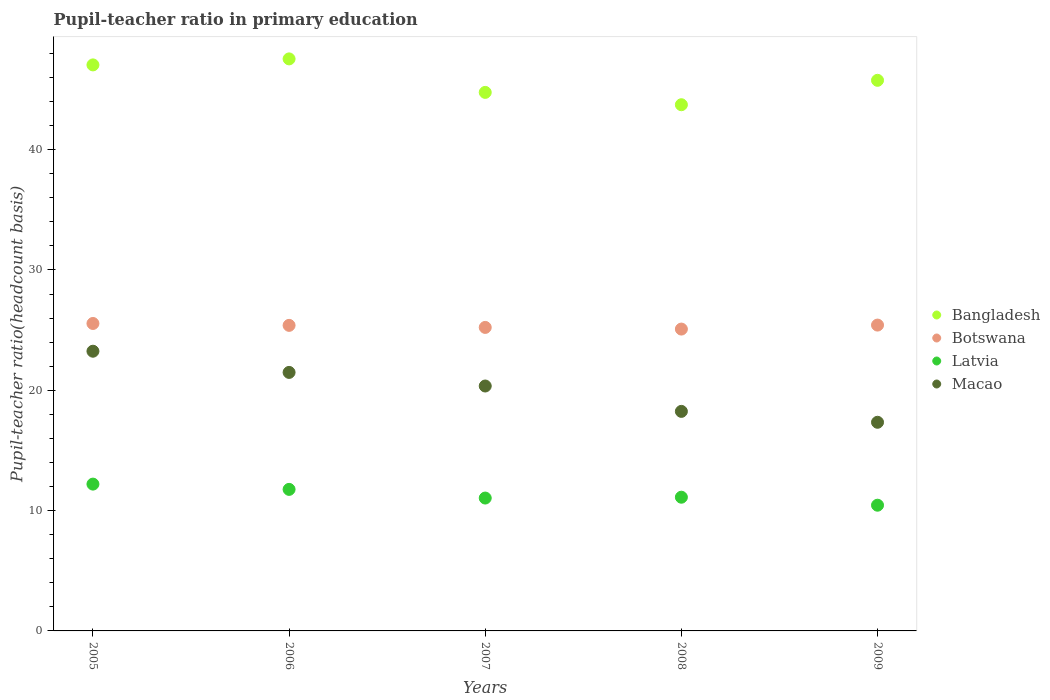What is the pupil-teacher ratio in primary education in Macao in 2007?
Ensure brevity in your answer.  20.35. Across all years, what is the maximum pupil-teacher ratio in primary education in Latvia?
Offer a terse response. 12.2. Across all years, what is the minimum pupil-teacher ratio in primary education in Botswana?
Make the answer very short. 25.08. What is the total pupil-teacher ratio in primary education in Botswana in the graph?
Provide a short and direct response. 126.67. What is the difference between the pupil-teacher ratio in primary education in Macao in 2005 and that in 2007?
Provide a short and direct response. 2.89. What is the difference between the pupil-teacher ratio in primary education in Latvia in 2005 and the pupil-teacher ratio in primary education in Bangladesh in 2008?
Provide a succinct answer. -31.53. What is the average pupil-teacher ratio in primary education in Botswana per year?
Your response must be concise. 25.33. In the year 2007, what is the difference between the pupil-teacher ratio in primary education in Bangladesh and pupil-teacher ratio in primary education in Macao?
Your answer should be compact. 24.4. In how many years, is the pupil-teacher ratio in primary education in Botswana greater than 22?
Keep it short and to the point. 5. What is the ratio of the pupil-teacher ratio in primary education in Macao in 2006 to that in 2009?
Make the answer very short. 1.24. Is the difference between the pupil-teacher ratio in primary education in Bangladesh in 2005 and 2007 greater than the difference between the pupil-teacher ratio in primary education in Macao in 2005 and 2007?
Keep it short and to the point. No. What is the difference between the highest and the second highest pupil-teacher ratio in primary education in Macao?
Provide a short and direct response. 1.76. What is the difference between the highest and the lowest pupil-teacher ratio in primary education in Latvia?
Give a very brief answer. 1.75. In how many years, is the pupil-teacher ratio in primary education in Macao greater than the average pupil-teacher ratio in primary education in Macao taken over all years?
Provide a short and direct response. 3. Is the sum of the pupil-teacher ratio in primary education in Botswana in 2005 and 2008 greater than the maximum pupil-teacher ratio in primary education in Latvia across all years?
Your response must be concise. Yes. Does the pupil-teacher ratio in primary education in Macao monotonically increase over the years?
Your answer should be very brief. No. Is the pupil-teacher ratio in primary education in Bangladesh strictly greater than the pupil-teacher ratio in primary education in Macao over the years?
Offer a terse response. Yes. How many dotlines are there?
Your answer should be compact. 4. How many years are there in the graph?
Make the answer very short. 5. What is the difference between two consecutive major ticks on the Y-axis?
Keep it short and to the point. 10. Does the graph contain any zero values?
Your answer should be very brief. No. Does the graph contain grids?
Offer a very short reply. No. Where does the legend appear in the graph?
Your answer should be compact. Center right. How are the legend labels stacked?
Provide a short and direct response. Vertical. What is the title of the graph?
Your answer should be compact. Pupil-teacher ratio in primary education. What is the label or title of the Y-axis?
Provide a succinct answer. Pupil-teacher ratio(headcount basis). What is the Pupil-teacher ratio(headcount basis) in Bangladesh in 2005?
Your answer should be very brief. 47.04. What is the Pupil-teacher ratio(headcount basis) of Botswana in 2005?
Your answer should be very brief. 25.55. What is the Pupil-teacher ratio(headcount basis) in Latvia in 2005?
Your answer should be very brief. 12.2. What is the Pupil-teacher ratio(headcount basis) in Macao in 2005?
Make the answer very short. 23.24. What is the Pupil-teacher ratio(headcount basis) of Bangladesh in 2006?
Ensure brevity in your answer.  47.54. What is the Pupil-teacher ratio(headcount basis) in Botswana in 2006?
Provide a succinct answer. 25.39. What is the Pupil-teacher ratio(headcount basis) of Latvia in 2006?
Ensure brevity in your answer.  11.76. What is the Pupil-teacher ratio(headcount basis) in Macao in 2006?
Make the answer very short. 21.48. What is the Pupil-teacher ratio(headcount basis) of Bangladesh in 2007?
Offer a very short reply. 44.75. What is the Pupil-teacher ratio(headcount basis) in Botswana in 2007?
Offer a terse response. 25.22. What is the Pupil-teacher ratio(headcount basis) of Latvia in 2007?
Offer a terse response. 11.04. What is the Pupil-teacher ratio(headcount basis) in Macao in 2007?
Make the answer very short. 20.35. What is the Pupil-teacher ratio(headcount basis) of Bangladesh in 2008?
Give a very brief answer. 43.73. What is the Pupil-teacher ratio(headcount basis) of Botswana in 2008?
Ensure brevity in your answer.  25.08. What is the Pupil-teacher ratio(headcount basis) of Latvia in 2008?
Your response must be concise. 11.11. What is the Pupil-teacher ratio(headcount basis) of Macao in 2008?
Your answer should be very brief. 18.24. What is the Pupil-teacher ratio(headcount basis) of Bangladesh in 2009?
Provide a short and direct response. 45.76. What is the Pupil-teacher ratio(headcount basis) of Botswana in 2009?
Offer a very short reply. 25.42. What is the Pupil-teacher ratio(headcount basis) in Latvia in 2009?
Give a very brief answer. 10.45. What is the Pupil-teacher ratio(headcount basis) of Macao in 2009?
Offer a very short reply. 17.34. Across all years, what is the maximum Pupil-teacher ratio(headcount basis) in Bangladesh?
Provide a succinct answer. 47.54. Across all years, what is the maximum Pupil-teacher ratio(headcount basis) in Botswana?
Your answer should be very brief. 25.55. Across all years, what is the maximum Pupil-teacher ratio(headcount basis) of Latvia?
Provide a succinct answer. 12.2. Across all years, what is the maximum Pupil-teacher ratio(headcount basis) in Macao?
Provide a succinct answer. 23.24. Across all years, what is the minimum Pupil-teacher ratio(headcount basis) of Bangladesh?
Keep it short and to the point. 43.73. Across all years, what is the minimum Pupil-teacher ratio(headcount basis) of Botswana?
Offer a very short reply. 25.08. Across all years, what is the minimum Pupil-teacher ratio(headcount basis) in Latvia?
Give a very brief answer. 10.45. Across all years, what is the minimum Pupil-teacher ratio(headcount basis) in Macao?
Your answer should be compact. 17.34. What is the total Pupil-teacher ratio(headcount basis) in Bangladesh in the graph?
Provide a short and direct response. 228.82. What is the total Pupil-teacher ratio(headcount basis) in Botswana in the graph?
Provide a succinct answer. 126.67. What is the total Pupil-teacher ratio(headcount basis) of Latvia in the graph?
Make the answer very short. 56.57. What is the total Pupil-teacher ratio(headcount basis) of Macao in the graph?
Your response must be concise. 100.67. What is the difference between the Pupil-teacher ratio(headcount basis) in Bangladesh in 2005 and that in 2006?
Your response must be concise. -0.5. What is the difference between the Pupil-teacher ratio(headcount basis) of Botswana in 2005 and that in 2006?
Make the answer very short. 0.16. What is the difference between the Pupil-teacher ratio(headcount basis) in Latvia in 2005 and that in 2006?
Keep it short and to the point. 0.44. What is the difference between the Pupil-teacher ratio(headcount basis) in Macao in 2005 and that in 2006?
Your answer should be compact. 1.76. What is the difference between the Pupil-teacher ratio(headcount basis) of Bangladesh in 2005 and that in 2007?
Keep it short and to the point. 2.28. What is the difference between the Pupil-teacher ratio(headcount basis) of Botswana in 2005 and that in 2007?
Your answer should be compact. 0.33. What is the difference between the Pupil-teacher ratio(headcount basis) in Latvia in 2005 and that in 2007?
Your response must be concise. 1.16. What is the difference between the Pupil-teacher ratio(headcount basis) of Macao in 2005 and that in 2007?
Offer a very short reply. 2.89. What is the difference between the Pupil-teacher ratio(headcount basis) of Bangladesh in 2005 and that in 2008?
Offer a very short reply. 3.31. What is the difference between the Pupil-teacher ratio(headcount basis) in Botswana in 2005 and that in 2008?
Keep it short and to the point. 0.47. What is the difference between the Pupil-teacher ratio(headcount basis) of Latvia in 2005 and that in 2008?
Offer a terse response. 1.09. What is the difference between the Pupil-teacher ratio(headcount basis) of Macao in 2005 and that in 2008?
Offer a terse response. 5. What is the difference between the Pupil-teacher ratio(headcount basis) of Bangladesh in 2005 and that in 2009?
Offer a terse response. 1.28. What is the difference between the Pupil-teacher ratio(headcount basis) of Botswana in 2005 and that in 2009?
Ensure brevity in your answer.  0.13. What is the difference between the Pupil-teacher ratio(headcount basis) in Latvia in 2005 and that in 2009?
Ensure brevity in your answer.  1.75. What is the difference between the Pupil-teacher ratio(headcount basis) in Macao in 2005 and that in 2009?
Ensure brevity in your answer.  5.91. What is the difference between the Pupil-teacher ratio(headcount basis) in Bangladesh in 2006 and that in 2007?
Offer a terse response. 2.78. What is the difference between the Pupil-teacher ratio(headcount basis) of Botswana in 2006 and that in 2007?
Make the answer very short. 0.17. What is the difference between the Pupil-teacher ratio(headcount basis) in Latvia in 2006 and that in 2007?
Your answer should be very brief. 0.72. What is the difference between the Pupil-teacher ratio(headcount basis) in Macao in 2006 and that in 2007?
Your answer should be compact. 1.13. What is the difference between the Pupil-teacher ratio(headcount basis) in Bangladesh in 2006 and that in 2008?
Keep it short and to the point. 3.81. What is the difference between the Pupil-teacher ratio(headcount basis) of Botswana in 2006 and that in 2008?
Keep it short and to the point. 0.31. What is the difference between the Pupil-teacher ratio(headcount basis) in Latvia in 2006 and that in 2008?
Give a very brief answer. 0.65. What is the difference between the Pupil-teacher ratio(headcount basis) in Macao in 2006 and that in 2008?
Your response must be concise. 3.24. What is the difference between the Pupil-teacher ratio(headcount basis) in Bangladesh in 2006 and that in 2009?
Ensure brevity in your answer.  1.78. What is the difference between the Pupil-teacher ratio(headcount basis) in Botswana in 2006 and that in 2009?
Your answer should be very brief. -0.02. What is the difference between the Pupil-teacher ratio(headcount basis) in Latvia in 2006 and that in 2009?
Give a very brief answer. 1.31. What is the difference between the Pupil-teacher ratio(headcount basis) of Macao in 2006 and that in 2009?
Provide a succinct answer. 4.14. What is the difference between the Pupil-teacher ratio(headcount basis) in Bangladesh in 2007 and that in 2008?
Make the answer very short. 1.03. What is the difference between the Pupil-teacher ratio(headcount basis) of Botswana in 2007 and that in 2008?
Ensure brevity in your answer.  0.14. What is the difference between the Pupil-teacher ratio(headcount basis) in Latvia in 2007 and that in 2008?
Make the answer very short. -0.07. What is the difference between the Pupil-teacher ratio(headcount basis) of Macao in 2007 and that in 2008?
Provide a short and direct response. 2.11. What is the difference between the Pupil-teacher ratio(headcount basis) of Bangladesh in 2007 and that in 2009?
Offer a very short reply. -1. What is the difference between the Pupil-teacher ratio(headcount basis) of Botswana in 2007 and that in 2009?
Provide a short and direct response. -0.19. What is the difference between the Pupil-teacher ratio(headcount basis) in Latvia in 2007 and that in 2009?
Give a very brief answer. 0.59. What is the difference between the Pupil-teacher ratio(headcount basis) in Macao in 2007 and that in 2009?
Keep it short and to the point. 3.01. What is the difference between the Pupil-teacher ratio(headcount basis) in Bangladesh in 2008 and that in 2009?
Give a very brief answer. -2.03. What is the difference between the Pupil-teacher ratio(headcount basis) in Botswana in 2008 and that in 2009?
Provide a succinct answer. -0.33. What is the difference between the Pupil-teacher ratio(headcount basis) in Latvia in 2008 and that in 2009?
Make the answer very short. 0.66. What is the difference between the Pupil-teacher ratio(headcount basis) in Macao in 2008 and that in 2009?
Make the answer very short. 0.91. What is the difference between the Pupil-teacher ratio(headcount basis) of Bangladesh in 2005 and the Pupil-teacher ratio(headcount basis) of Botswana in 2006?
Your answer should be very brief. 21.65. What is the difference between the Pupil-teacher ratio(headcount basis) in Bangladesh in 2005 and the Pupil-teacher ratio(headcount basis) in Latvia in 2006?
Your answer should be compact. 35.28. What is the difference between the Pupil-teacher ratio(headcount basis) in Bangladesh in 2005 and the Pupil-teacher ratio(headcount basis) in Macao in 2006?
Offer a very short reply. 25.56. What is the difference between the Pupil-teacher ratio(headcount basis) in Botswana in 2005 and the Pupil-teacher ratio(headcount basis) in Latvia in 2006?
Offer a terse response. 13.79. What is the difference between the Pupil-teacher ratio(headcount basis) in Botswana in 2005 and the Pupil-teacher ratio(headcount basis) in Macao in 2006?
Keep it short and to the point. 4.07. What is the difference between the Pupil-teacher ratio(headcount basis) of Latvia in 2005 and the Pupil-teacher ratio(headcount basis) of Macao in 2006?
Give a very brief answer. -9.28. What is the difference between the Pupil-teacher ratio(headcount basis) in Bangladesh in 2005 and the Pupil-teacher ratio(headcount basis) in Botswana in 2007?
Offer a very short reply. 21.82. What is the difference between the Pupil-teacher ratio(headcount basis) of Bangladesh in 2005 and the Pupil-teacher ratio(headcount basis) of Latvia in 2007?
Provide a short and direct response. 36. What is the difference between the Pupil-teacher ratio(headcount basis) of Bangladesh in 2005 and the Pupil-teacher ratio(headcount basis) of Macao in 2007?
Offer a very short reply. 26.69. What is the difference between the Pupil-teacher ratio(headcount basis) in Botswana in 2005 and the Pupil-teacher ratio(headcount basis) in Latvia in 2007?
Give a very brief answer. 14.51. What is the difference between the Pupil-teacher ratio(headcount basis) in Botswana in 2005 and the Pupil-teacher ratio(headcount basis) in Macao in 2007?
Provide a succinct answer. 5.2. What is the difference between the Pupil-teacher ratio(headcount basis) in Latvia in 2005 and the Pupil-teacher ratio(headcount basis) in Macao in 2007?
Keep it short and to the point. -8.15. What is the difference between the Pupil-teacher ratio(headcount basis) of Bangladesh in 2005 and the Pupil-teacher ratio(headcount basis) of Botswana in 2008?
Provide a succinct answer. 21.95. What is the difference between the Pupil-teacher ratio(headcount basis) of Bangladesh in 2005 and the Pupil-teacher ratio(headcount basis) of Latvia in 2008?
Provide a short and direct response. 35.93. What is the difference between the Pupil-teacher ratio(headcount basis) in Bangladesh in 2005 and the Pupil-teacher ratio(headcount basis) in Macao in 2008?
Give a very brief answer. 28.79. What is the difference between the Pupil-teacher ratio(headcount basis) in Botswana in 2005 and the Pupil-teacher ratio(headcount basis) in Latvia in 2008?
Provide a succinct answer. 14.44. What is the difference between the Pupil-teacher ratio(headcount basis) of Botswana in 2005 and the Pupil-teacher ratio(headcount basis) of Macao in 2008?
Provide a short and direct response. 7.31. What is the difference between the Pupil-teacher ratio(headcount basis) of Latvia in 2005 and the Pupil-teacher ratio(headcount basis) of Macao in 2008?
Give a very brief answer. -6.04. What is the difference between the Pupil-teacher ratio(headcount basis) of Bangladesh in 2005 and the Pupil-teacher ratio(headcount basis) of Botswana in 2009?
Your answer should be very brief. 21.62. What is the difference between the Pupil-teacher ratio(headcount basis) in Bangladesh in 2005 and the Pupil-teacher ratio(headcount basis) in Latvia in 2009?
Provide a short and direct response. 36.59. What is the difference between the Pupil-teacher ratio(headcount basis) in Bangladesh in 2005 and the Pupil-teacher ratio(headcount basis) in Macao in 2009?
Offer a terse response. 29.7. What is the difference between the Pupil-teacher ratio(headcount basis) of Botswana in 2005 and the Pupil-teacher ratio(headcount basis) of Latvia in 2009?
Provide a succinct answer. 15.1. What is the difference between the Pupil-teacher ratio(headcount basis) in Botswana in 2005 and the Pupil-teacher ratio(headcount basis) in Macao in 2009?
Your answer should be very brief. 8.21. What is the difference between the Pupil-teacher ratio(headcount basis) of Latvia in 2005 and the Pupil-teacher ratio(headcount basis) of Macao in 2009?
Provide a short and direct response. -5.14. What is the difference between the Pupil-teacher ratio(headcount basis) in Bangladesh in 2006 and the Pupil-teacher ratio(headcount basis) in Botswana in 2007?
Give a very brief answer. 22.32. What is the difference between the Pupil-teacher ratio(headcount basis) of Bangladesh in 2006 and the Pupil-teacher ratio(headcount basis) of Latvia in 2007?
Keep it short and to the point. 36.5. What is the difference between the Pupil-teacher ratio(headcount basis) of Bangladesh in 2006 and the Pupil-teacher ratio(headcount basis) of Macao in 2007?
Give a very brief answer. 27.19. What is the difference between the Pupil-teacher ratio(headcount basis) of Botswana in 2006 and the Pupil-teacher ratio(headcount basis) of Latvia in 2007?
Your answer should be very brief. 14.35. What is the difference between the Pupil-teacher ratio(headcount basis) of Botswana in 2006 and the Pupil-teacher ratio(headcount basis) of Macao in 2007?
Ensure brevity in your answer.  5.04. What is the difference between the Pupil-teacher ratio(headcount basis) of Latvia in 2006 and the Pupil-teacher ratio(headcount basis) of Macao in 2007?
Ensure brevity in your answer.  -8.59. What is the difference between the Pupil-teacher ratio(headcount basis) in Bangladesh in 2006 and the Pupil-teacher ratio(headcount basis) in Botswana in 2008?
Make the answer very short. 22.45. What is the difference between the Pupil-teacher ratio(headcount basis) in Bangladesh in 2006 and the Pupil-teacher ratio(headcount basis) in Latvia in 2008?
Your response must be concise. 36.43. What is the difference between the Pupil-teacher ratio(headcount basis) in Bangladesh in 2006 and the Pupil-teacher ratio(headcount basis) in Macao in 2008?
Ensure brevity in your answer.  29.29. What is the difference between the Pupil-teacher ratio(headcount basis) in Botswana in 2006 and the Pupil-teacher ratio(headcount basis) in Latvia in 2008?
Make the answer very short. 14.28. What is the difference between the Pupil-teacher ratio(headcount basis) in Botswana in 2006 and the Pupil-teacher ratio(headcount basis) in Macao in 2008?
Offer a terse response. 7.15. What is the difference between the Pupil-teacher ratio(headcount basis) of Latvia in 2006 and the Pupil-teacher ratio(headcount basis) of Macao in 2008?
Provide a succinct answer. -6.48. What is the difference between the Pupil-teacher ratio(headcount basis) in Bangladesh in 2006 and the Pupil-teacher ratio(headcount basis) in Botswana in 2009?
Give a very brief answer. 22.12. What is the difference between the Pupil-teacher ratio(headcount basis) of Bangladesh in 2006 and the Pupil-teacher ratio(headcount basis) of Latvia in 2009?
Provide a short and direct response. 37.09. What is the difference between the Pupil-teacher ratio(headcount basis) in Bangladesh in 2006 and the Pupil-teacher ratio(headcount basis) in Macao in 2009?
Your response must be concise. 30.2. What is the difference between the Pupil-teacher ratio(headcount basis) of Botswana in 2006 and the Pupil-teacher ratio(headcount basis) of Latvia in 2009?
Offer a very short reply. 14.95. What is the difference between the Pupil-teacher ratio(headcount basis) in Botswana in 2006 and the Pupil-teacher ratio(headcount basis) in Macao in 2009?
Offer a very short reply. 8.05. What is the difference between the Pupil-teacher ratio(headcount basis) in Latvia in 2006 and the Pupil-teacher ratio(headcount basis) in Macao in 2009?
Offer a very short reply. -5.58. What is the difference between the Pupil-teacher ratio(headcount basis) of Bangladesh in 2007 and the Pupil-teacher ratio(headcount basis) of Botswana in 2008?
Ensure brevity in your answer.  19.67. What is the difference between the Pupil-teacher ratio(headcount basis) in Bangladesh in 2007 and the Pupil-teacher ratio(headcount basis) in Latvia in 2008?
Offer a very short reply. 33.64. What is the difference between the Pupil-teacher ratio(headcount basis) of Bangladesh in 2007 and the Pupil-teacher ratio(headcount basis) of Macao in 2008?
Your answer should be very brief. 26.51. What is the difference between the Pupil-teacher ratio(headcount basis) in Botswana in 2007 and the Pupil-teacher ratio(headcount basis) in Latvia in 2008?
Make the answer very short. 14.11. What is the difference between the Pupil-teacher ratio(headcount basis) in Botswana in 2007 and the Pupil-teacher ratio(headcount basis) in Macao in 2008?
Your answer should be compact. 6.98. What is the difference between the Pupil-teacher ratio(headcount basis) of Latvia in 2007 and the Pupil-teacher ratio(headcount basis) of Macao in 2008?
Your answer should be very brief. -7.2. What is the difference between the Pupil-teacher ratio(headcount basis) of Bangladesh in 2007 and the Pupil-teacher ratio(headcount basis) of Botswana in 2009?
Provide a short and direct response. 19.34. What is the difference between the Pupil-teacher ratio(headcount basis) in Bangladesh in 2007 and the Pupil-teacher ratio(headcount basis) in Latvia in 2009?
Offer a very short reply. 34.31. What is the difference between the Pupil-teacher ratio(headcount basis) in Bangladesh in 2007 and the Pupil-teacher ratio(headcount basis) in Macao in 2009?
Ensure brevity in your answer.  27.42. What is the difference between the Pupil-teacher ratio(headcount basis) of Botswana in 2007 and the Pupil-teacher ratio(headcount basis) of Latvia in 2009?
Your answer should be very brief. 14.77. What is the difference between the Pupil-teacher ratio(headcount basis) in Botswana in 2007 and the Pupil-teacher ratio(headcount basis) in Macao in 2009?
Ensure brevity in your answer.  7.88. What is the difference between the Pupil-teacher ratio(headcount basis) of Latvia in 2007 and the Pupil-teacher ratio(headcount basis) of Macao in 2009?
Make the answer very short. -6.3. What is the difference between the Pupil-teacher ratio(headcount basis) in Bangladesh in 2008 and the Pupil-teacher ratio(headcount basis) in Botswana in 2009?
Ensure brevity in your answer.  18.31. What is the difference between the Pupil-teacher ratio(headcount basis) of Bangladesh in 2008 and the Pupil-teacher ratio(headcount basis) of Latvia in 2009?
Offer a very short reply. 33.28. What is the difference between the Pupil-teacher ratio(headcount basis) in Bangladesh in 2008 and the Pupil-teacher ratio(headcount basis) in Macao in 2009?
Give a very brief answer. 26.39. What is the difference between the Pupil-teacher ratio(headcount basis) of Botswana in 2008 and the Pupil-teacher ratio(headcount basis) of Latvia in 2009?
Give a very brief answer. 14.64. What is the difference between the Pupil-teacher ratio(headcount basis) in Botswana in 2008 and the Pupil-teacher ratio(headcount basis) in Macao in 2009?
Ensure brevity in your answer.  7.75. What is the difference between the Pupil-teacher ratio(headcount basis) of Latvia in 2008 and the Pupil-teacher ratio(headcount basis) of Macao in 2009?
Offer a terse response. -6.23. What is the average Pupil-teacher ratio(headcount basis) in Bangladesh per year?
Your answer should be compact. 45.76. What is the average Pupil-teacher ratio(headcount basis) of Botswana per year?
Provide a succinct answer. 25.33. What is the average Pupil-teacher ratio(headcount basis) in Latvia per year?
Ensure brevity in your answer.  11.31. What is the average Pupil-teacher ratio(headcount basis) in Macao per year?
Make the answer very short. 20.13. In the year 2005, what is the difference between the Pupil-teacher ratio(headcount basis) in Bangladesh and Pupil-teacher ratio(headcount basis) in Botswana?
Give a very brief answer. 21.49. In the year 2005, what is the difference between the Pupil-teacher ratio(headcount basis) of Bangladesh and Pupil-teacher ratio(headcount basis) of Latvia?
Your answer should be very brief. 34.84. In the year 2005, what is the difference between the Pupil-teacher ratio(headcount basis) of Bangladesh and Pupil-teacher ratio(headcount basis) of Macao?
Provide a short and direct response. 23.79. In the year 2005, what is the difference between the Pupil-teacher ratio(headcount basis) in Botswana and Pupil-teacher ratio(headcount basis) in Latvia?
Your response must be concise. 13.35. In the year 2005, what is the difference between the Pupil-teacher ratio(headcount basis) of Botswana and Pupil-teacher ratio(headcount basis) of Macao?
Give a very brief answer. 2.31. In the year 2005, what is the difference between the Pupil-teacher ratio(headcount basis) of Latvia and Pupil-teacher ratio(headcount basis) of Macao?
Offer a very short reply. -11.04. In the year 2006, what is the difference between the Pupil-teacher ratio(headcount basis) in Bangladesh and Pupil-teacher ratio(headcount basis) in Botswana?
Offer a very short reply. 22.15. In the year 2006, what is the difference between the Pupil-teacher ratio(headcount basis) of Bangladesh and Pupil-teacher ratio(headcount basis) of Latvia?
Make the answer very short. 35.78. In the year 2006, what is the difference between the Pupil-teacher ratio(headcount basis) of Bangladesh and Pupil-teacher ratio(headcount basis) of Macao?
Make the answer very short. 26.06. In the year 2006, what is the difference between the Pupil-teacher ratio(headcount basis) of Botswana and Pupil-teacher ratio(headcount basis) of Latvia?
Ensure brevity in your answer.  13.63. In the year 2006, what is the difference between the Pupil-teacher ratio(headcount basis) in Botswana and Pupil-teacher ratio(headcount basis) in Macao?
Provide a succinct answer. 3.91. In the year 2006, what is the difference between the Pupil-teacher ratio(headcount basis) of Latvia and Pupil-teacher ratio(headcount basis) of Macao?
Provide a succinct answer. -9.72. In the year 2007, what is the difference between the Pupil-teacher ratio(headcount basis) of Bangladesh and Pupil-teacher ratio(headcount basis) of Botswana?
Your response must be concise. 19.53. In the year 2007, what is the difference between the Pupil-teacher ratio(headcount basis) in Bangladesh and Pupil-teacher ratio(headcount basis) in Latvia?
Ensure brevity in your answer.  33.71. In the year 2007, what is the difference between the Pupil-teacher ratio(headcount basis) in Bangladesh and Pupil-teacher ratio(headcount basis) in Macao?
Ensure brevity in your answer.  24.4. In the year 2007, what is the difference between the Pupil-teacher ratio(headcount basis) in Botswana and Pupil-teacher ratio(headcount basis) in Latvia?
Ensure brevity in your answer.  14.18. In the year 2007, what is the difference between the Pupil-teacher ratio(headcount basis) in Botswana and Pupil-teacher ratio(headcount basis) in Macao?
Make the answer very short. 4.87. In the year 2007, what is the difference between the Pupil-teacher ratio(headcount basis) in Latvia and Pupil-teacher ratio(headcount basis) in Macao?
Offer a terse response. -9.31. In the year 2008, what is the difference between the Pupil-teacher ratio(headcount basis) in Bangladesh and Pupil-teacher ratio(headcount basis) in Botswana?
Offer a very short reply. 18.64. In the year 2008, what is the difference between the Pupil-teacher ratio(headcount basis) of Bangladesh and Pupil-teacher ratio(headcount basis) of Latvia?
Give a very brief answer. 32.62. In the year 2008, what is the difference between the Pupil-teacher ratio(headcount basis) of Bangladesh and Pupil-teacher ratio(headcount basis) of Macao?
Keep it short and to the point. 25.48. In the year 2008, what is the difference between the Pupil-teacher ratio(headcount basis) of Botswana and Pupil-teacher ratio(headcount basis) of Latvia?
Offer a very short reply. 13.97. In the year 2008, what is the difference between the Pupil-teacher ratio(headcount basis) in Botswana and Pupil-teacher ratio(headcount basis) in Macao?
Provide a short and direct response. 6.84. In the year 2008, what is the difference between the Pupil-teacher ratio(headcount basis) in Latvia and Pupil-teacher ratio(headcount basis) in Macao?
Provide a succinct answer. -7.13. In the year 2009, what is the difference between the Pupil-teacher ratio(headcount basis) in Bangladesh and Pupil-teacher ratio(headcount basis) in Botswana?
Provide a succinct answer. 20.34. In the year 2009, what is the difference between the Pupil-teacher ratio(headcount basis) in Bangladesh and Pupil-teacher ratio(headcount basis) in Latvia?
Offer a terse response. 35.31. In the year 2009, what is the difference between the Pupil-teacher ratio(headcount basis) in Bangladesh and Pupil-teacher ratio(headcount basis) in Macao?
Give a very brief answer. 28.42. In the year 2009, what is the difference between the Pupil-teacher ratio(headcount basis) of Botswana and Pupil-teacher ratio(headcount basis) of Latvia?
Provide a succinct answer. 14.97. In the year 2009, what is the difference between the Pupil-teacher ratio(headcount basis) in Botswana and Pupil-teacher ratio(headcount basis) in Macao?
Your answer should be very brief. 8.08. In the year 2009, what is the difference between the Pupil-teacher ratio(headcount basis) of Latvia and Pupil-teacher ratio(headcount basis) of Macao?
Make the answer very short. -6.89. What is the ratio of the Pupil-teacher ratio(headcount basis) of Botswana in 2005 to that in 2006?
Ensure brevity in your answer.  1.01. What is the ratio of the Pupil-teacher ratio(headcount basis) of Latvia in 2005 to that in 2006?
Offer a very short reply. 1.04. What is the ratio of the Pupil-teacher ratio(headcount basis) of Macao in 2005 to that in 2006?
Provide a short and direct response. 1.08. What is the ratio of the Pupil-teacher ratio(headcount basis) of Bangladesh in 2005 to that in 2007?
Your answer should be compact. 1.05. What is the ratio of the Pupil-teacher ratio(headcount basis) in Botswana in 2005 to that in 2007?
Keep it short and to the point. 1.01. What is the ratio of the Pupil-teacher ratio(headcount basis) of Latvia in 2005 to that in 2007?
Provide a succinct answer. 1.1. What is the ratio of the Pupil-teacher ratio(headcount basis) of Macao in 2005 to that in 2007?
Give a very brief answer. 1.14. What is the ratio of the Pupil-teacher ratio(headcount basis) in Bangladesh in 2005 to that in 2008?
Offer a terse response. 1.08. What is the ratio of the Pupil-teacher ratio(headcount basis) of Botswana in 2005 to that in 2008?
Provide a succinct answer. 1.02. What is the ratio of the Pupil-teacher ratio(headcount basis) of Latvia in 2005 to that in 2008?
Ensure brevity in your answer.  1.1. What is the ratio of the Pupil-teacher ratio(headcount basis) in Macao in 2005 to that in 2008?
Ensure brevity in your answer.  1.27. What is the ratio of the Pupil-teacher ratio(headcount basis) in Bangladesh in 2005 to that in 2009?
Ensure brevity in your answer.  1.03. What is the ratio of the Pupil-teacher ratio(headcount basis) of Botswana in 2005 to that in 2009?
Offer a very short reply. 1.01. What is the ratio of the Pupil-teacher ratio(headcount basis) of Latvia in 2005 to that in 2009?
Provide a short and direct response. 1.17. What is the ratio of the Pupil-teacher ratio(headcount basis) in Macao in 2005 to that in 2009?
Your answer should be very brief. 1.34. What is the ratio of the Pupil-teacher ratio(headcount basis) of Bangladesh in 2006 to that in 2007?
Your answer should be compact. 1.06. What is the ratio of the Pupil-teacher ratio(headcount basis) in Botswana in 2006 to that in 2007?
Your answer should be compact. 1.01. What is the ratio of the Pupil-teacher ratio(headcount basis) of Latvia in 2006 to that in 2007?
Provide a short and direct response. 1.07. What is the ratio of the Pupil-teacher ratio(headcount basis) of Macao in 2006 to that in 2007?
Provide a succinct answer. 1.06. What is the ratio of the Pupil-teacher ratio(headcount basis) in Bangladesh in 2006 to that in 2008?
Offer a terse response. 1.09. What is the ratio of the Pupil-teacher ratio(headcount basis) in Botswana in 2006 to that in 2008?
Provide a succinct answer. 1.01. What is the ratio of the Pupil-teacher ratio(headcount basis) in Latvia in 2006 to that in 2008?
Provide a short and direct response. 1.06. What is the ratio of the Pupil-teacher ratio(headcount basis) in Macao in 2006 to that in 2008?
Offer a very short reply. 1.18. What is the ratio of the Pupil-teacher ratio(headcount basis) in Bangladesh in 2006 to that in 2009?
Give a very brief answer. 1.04. What is the ratio of the Pupil-teacher ratio(headcount basis) in Latvia in 2006 to that in 2009?
Offer a very short reply. 1.13. What is the ratio of the Pupil-teacher ratio(headcount basis) of Macao in 2006 to that in 2009?
Give a very brief answer. 1.24. What is the ratio of the Pupil-teacher ratio(headcount basis) in Bangladesh in 2007 to that in 2008?
Provide a succinct answer. 1.02. What is the ratio of the Pupil-teacher ratio(headcount basis) of Latvia in 2007 to that in 2008?
Provide a succinct answer. 0.99. What is the ratio of the Pupil-teacher ratio(headcount basis) in Macao in 2007 to that in 2008?
Ensure brevity in your answer.  1.12. What is the ratio of the Pupil-teacher ratio(headcount basis) in Bangladesh in 2007 to that in 2009?
Give a very brief answer. 0.98. What is the ratio of the Pupil-teacher ratio(headcount basis) in Latvia in 2007 to that in 2009?
Provide a short and direct response. 1.06. What is the ratio of the Pupil-teacher ratio(headcount basis) in Macao in 2007 to that in 2009?
Your response must be concise. 1.17. What is the ratio of the Pupil-teacher ratio(headcount basis) of Bangladesh in 2008 to that in 2009?
Provide a short and direct response. 0.96. What is the ratio of the Pupil-teacher ratio(headcount basis) of Botswana in 2008 to that in 2009?
Offer a terse response. 0.99. What is the ratio of the Pupil-teacher ratio(headcount basis) of Latvia in 2008 to that in 2009?
Keep it short and to the point. 1.06. What is the ratio of the Pupil-teacher ratio(headcount basis) in Macao in 2008 to that in 2009?
Your answer should be very brief. 1.05. What is the difference between the highest and the second highest Pupil-teacher ratio(headcount basis) in Bangladesh?
Provide a short and direct response. 0.5. What is the difference between the highest and the second highest Pupil-teacher ratio(headcount basis) in Botswana?
Give a very brief answer. 0.13. What is the difference between the highest and the second highest Pupil-teacher ratio(headcount basis) of Latvia?
Your answer should be very brief. 0.44. What is the difference between the highest and the second highest Pupil-teacher ratio(headcount basis) in Macao?
Make the answer very short. 1.76. What is the difference between the highest and the lowest Pupil-teacher ratio(headcount basis) of Bangladesh?
Make the answer very short. 3.81. What is the difference between the highest and the lowest Pupil-teacher ratio(headcount basis) in Botswana?
Your answer should be very brief. 0.47. What is the difference between the highest and the lowest Pupil-teacher ratio(headcount basis) of Latvia?
Your response must be concise. 1.75. What is the difference between the highest and the lowest Pupil-teacher ratio(headcount basis) of Macao?
Provide a short and direct response. 5.91. 